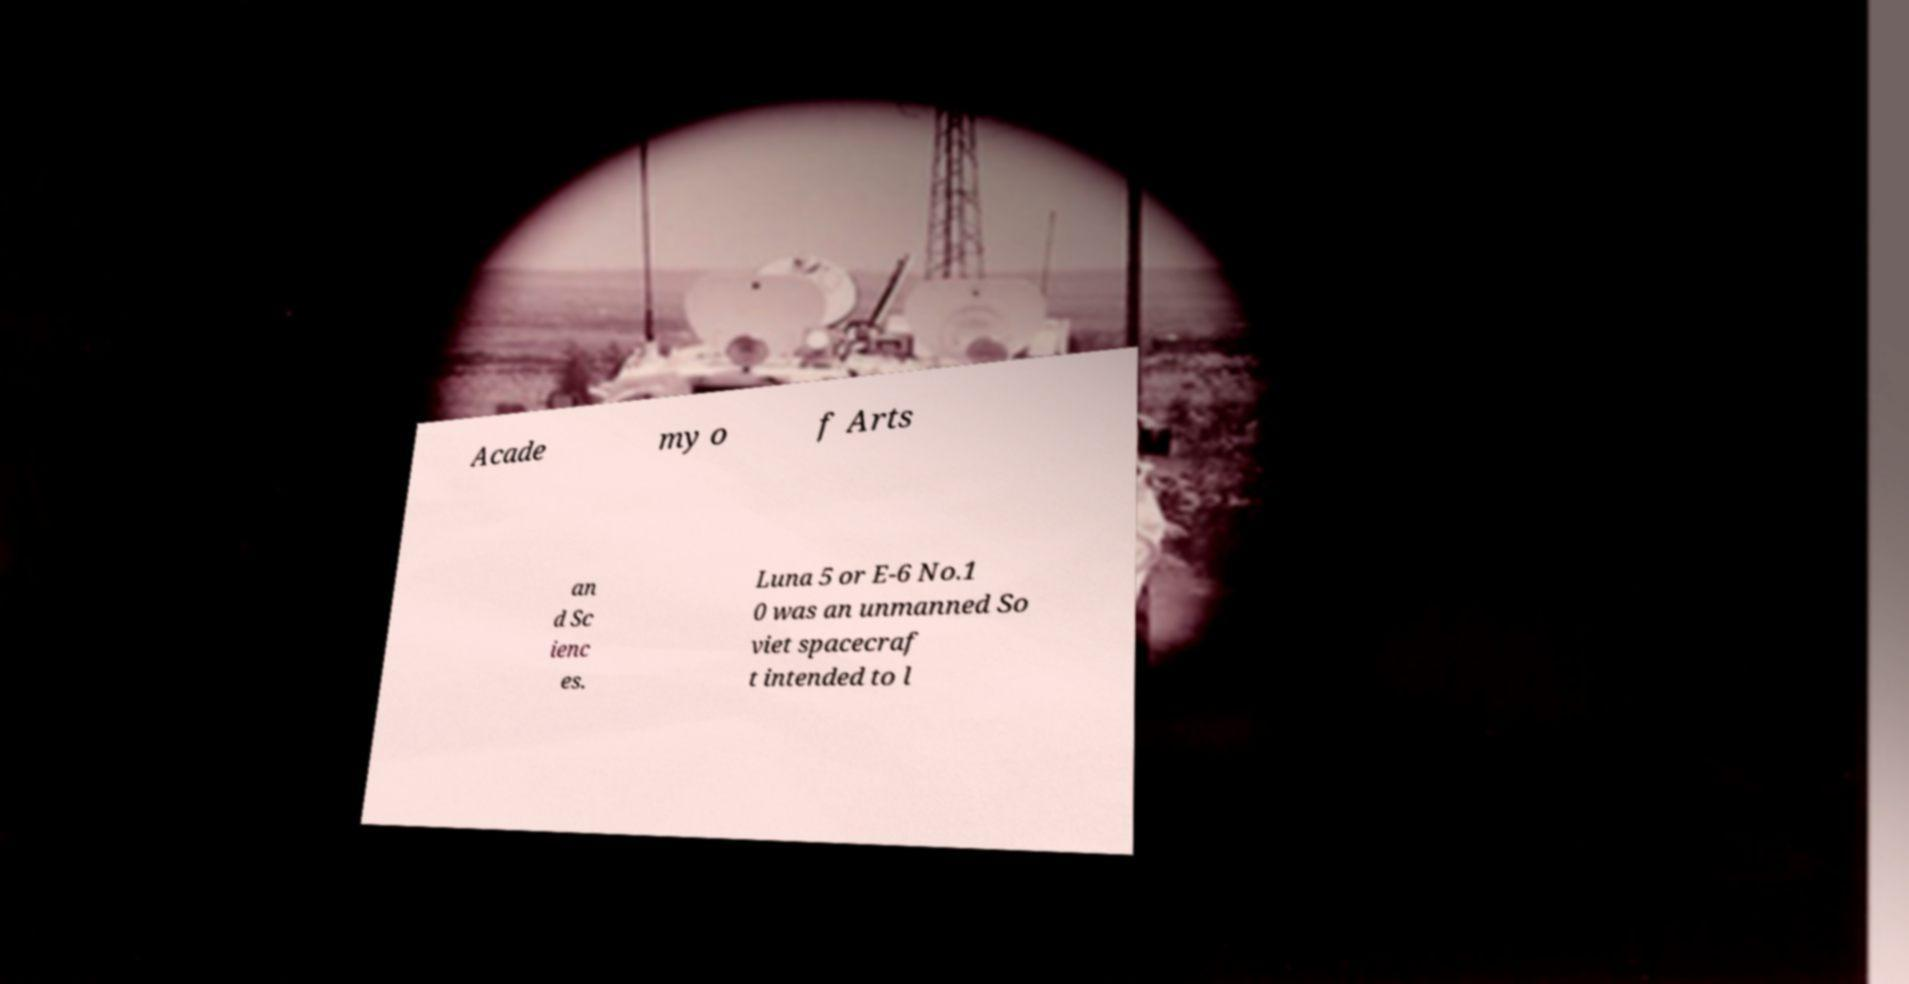Could you assist in decoding the text presented in this image and type it out clearly? Acade my o f Arts an d Sc ienc es. Luna 5 or E-6 No.1 0 was an unmanned So viet spacecraf t intended to l 